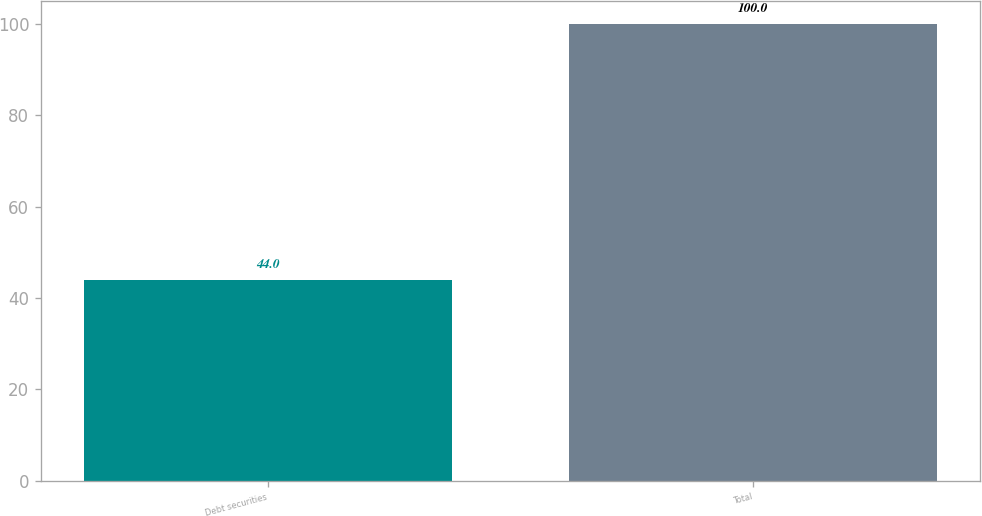Convert chart. <chart><loc_0><loc_0><loc_500><loc_500><bar_chart><fcel>Debt securities<fcel>Total<nl><fcel>44<fcel>100<nl></chart> 